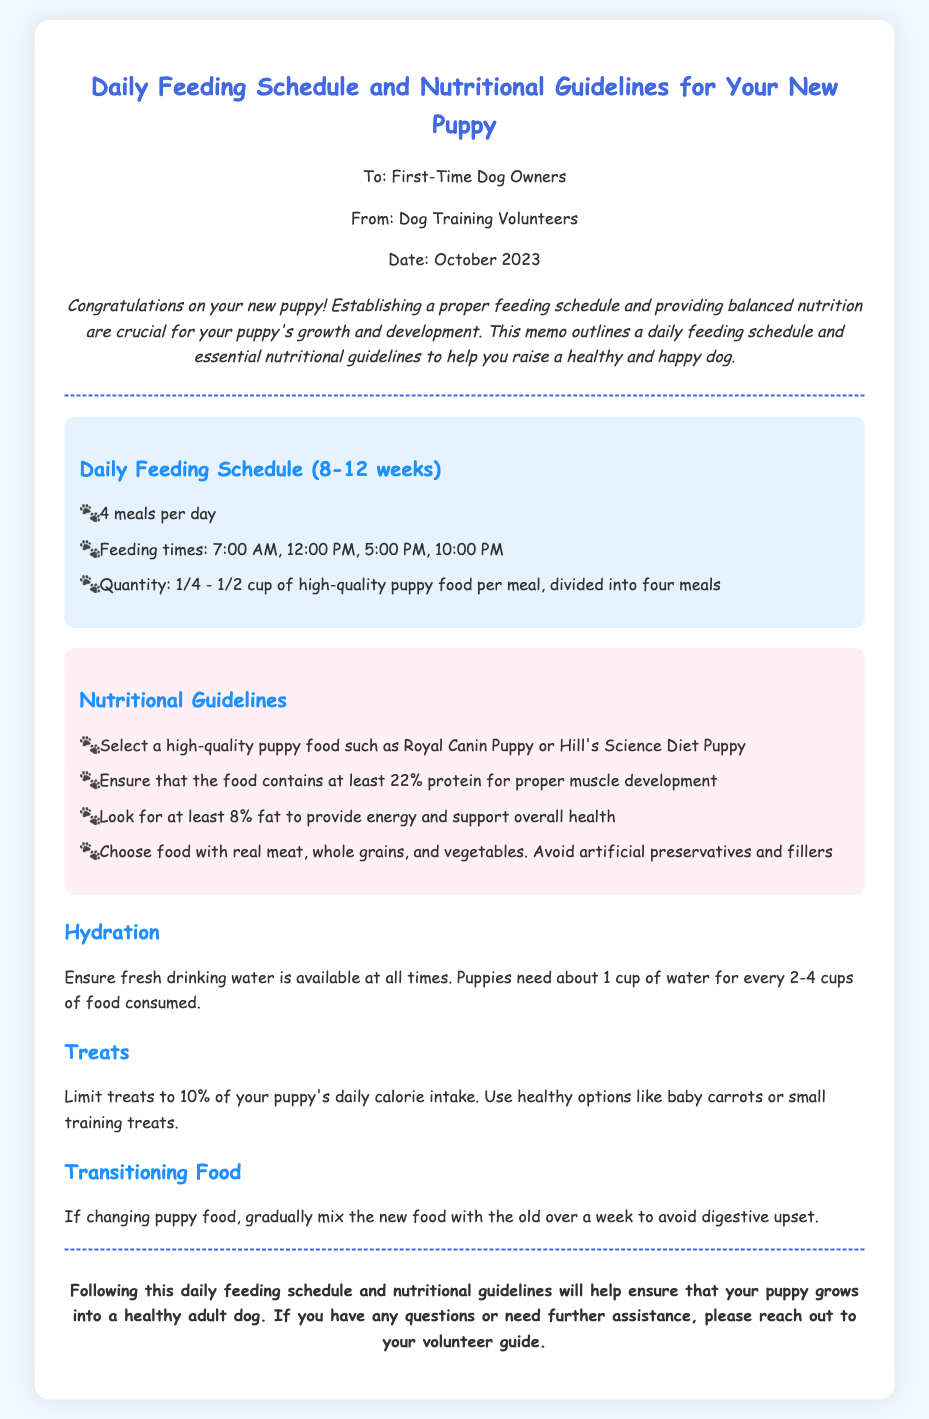What is the daily number of meals recommended for a puppy? The document specifies a feeding schedule that includes a total of four meals per day.
Answer: 4 meals What are the recommended feeding times? The memo lists the specific feeding times as 7:00 AM, 12:00 PM, 5:00 PM, and 10:00 PM.
Answer: 7:00 AM, 12:00 PM, 5:00 PM, 10:00 PM What is the quantity of puppy food per meal? The document states that the quantity of high-quality puppy food should be between 1/4 and 1/2 cup per meal.
Answer: 1/4 - 1/2 cup What percentage of protein should puppy food contain? The nutritional guidelines emphasize that the food must contain at least 22% protein for proper muscle development.
Answer: 22% What should treats not exceed in terms of daily calorie intake? The memo advises that treats should be limited to 10% of the puppy's daily calorie intake.
Answer: 10% What is the recommended brand of puppy food mentioned? The document suggests high-quality puppy food options including Royal Canin Puppy and Hill's Science Diet Puppy.
Answer: Royal Canin Puppy or Hill's Science Diet Puppy What should you do when transitioning to a new puppy food? The guidelines recommend gradually mixing the new food with the old food over a week to prevent digestive upset.
Answer: Gradually mix What is crucial to ensure for puppy hydration? The document highlights that fresh drinking water must be available at all times for puppies.
Answer: Fresh drinking water What is the purpose of the memo? The primary objective of the memo is to guide first-time dog owners on establishing a feeding schedule and providing nutritional guidelines for their new puppy.
Answer: Guide first-time dog owners 